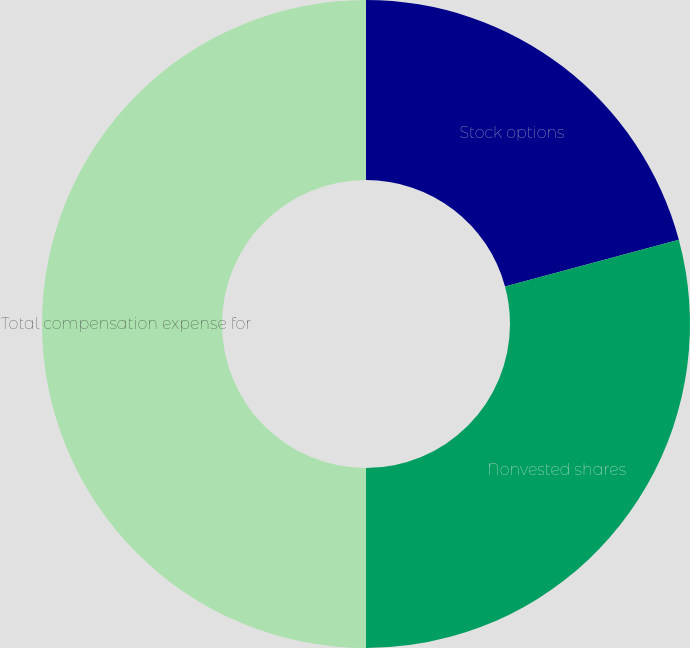Convert chart to OTSL. <chart><loc_0><loc_0><loc_500><loc_500><pie_chart><fcel>Stock options<fcel>Nonvested shares<fcel>Total compensation expense for<nl><fcel>20.81%<fcel>29.19%<fcel>50.0%<nl></chart> 